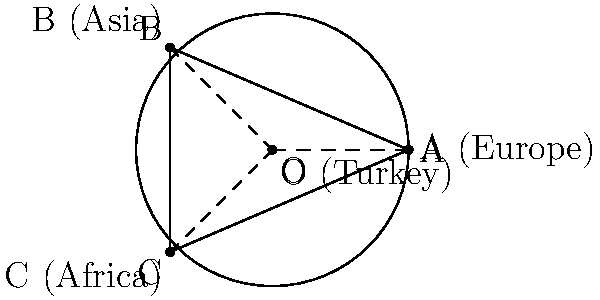In the circle above, point O represents Turkey's strategic position between Europe (A), Asia (B), and Africa (C). The inscribed angle $\angle BOC$ is 120°. What is the measure of the central angle $\angle AOC$, which represents Turkey's geopolitical span between Europe and Africa? To solve this problem, we'll use the relationship between inscribed angles and central angles in a circle:

1) First, recall that an inscribed angle is half the measure of the central angle that subtends the same arc.

2) We're given that $\angle BOC = 120°$. This is an inscribed angle.

3) Let's call the central angle we're looking for $\angle AOC = x°$.

4) The relationship between the inscribed angle $\angle BOC$ and the central angle $\angle AOC$ is:

   $$\angle BOC = \frac{1}{2} \angle AOC$$

5) Substituting the known value:

   $$120° = \frac{1}{2}x°$$

6) Multiply both sides by 2:

   $$2 \cdot 120° = x°$$

7) Simplify:

   $$240° = x°$$

Therefore, the measure of the central angle $\angle AOC$, representing Turkey's geopolitical span between Europe and Africa, is 240°.
Answer: 240° 